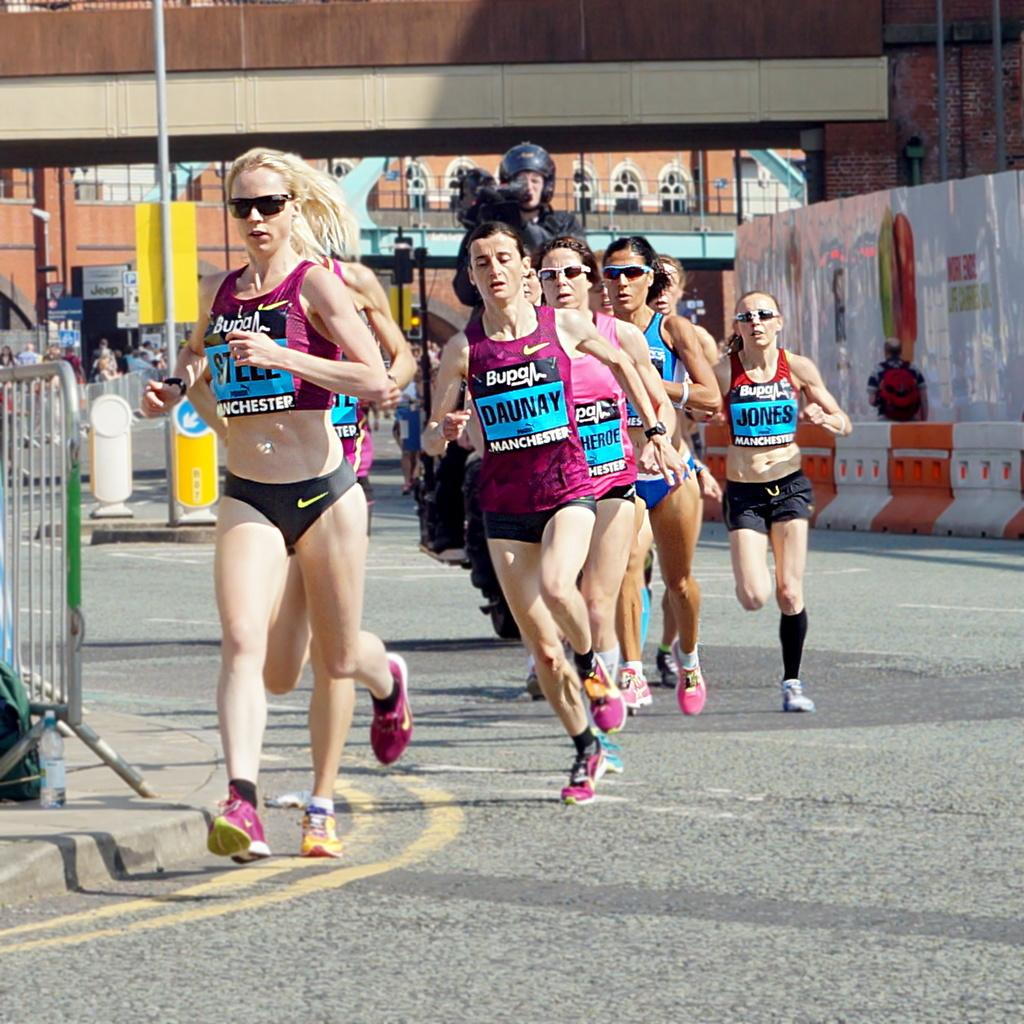What are the women in the image doing? The women in the image are running on the road. Can you describe the person in the image? There is a person holding a video camera in his hand in the image. What can be seen in the background of the image? There is a building visible in the background of the image. What type of pain is the person holding the video camera experiencing in the image? There is no indication in the image that the person holding the video camera is experiencing any pain. 